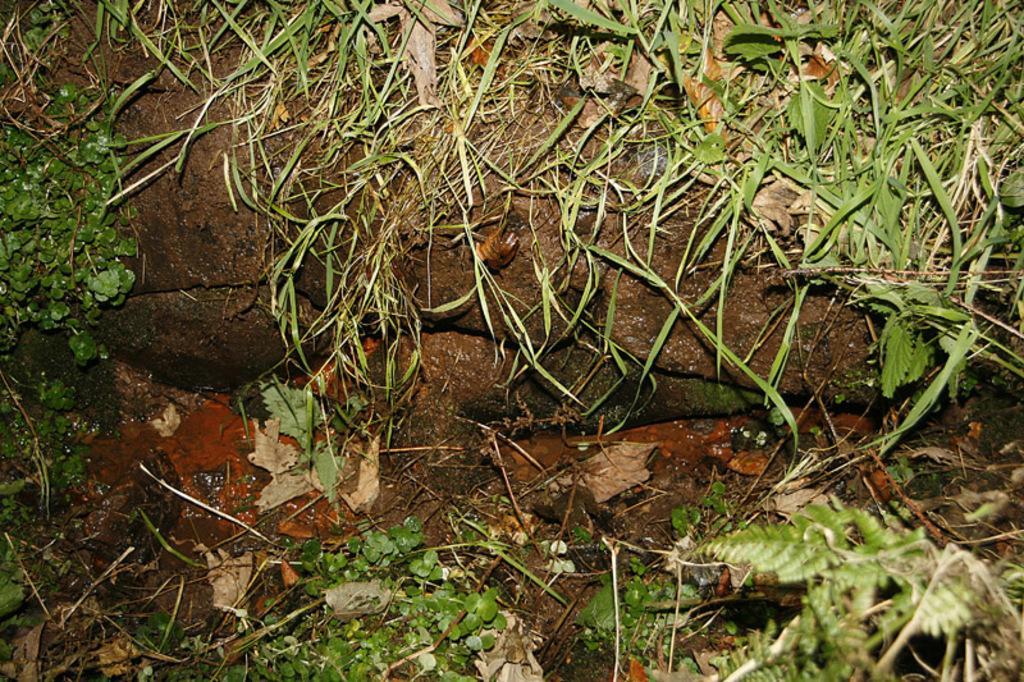How would you summarize this image in a sentence or two? In this picture we can see the wall and it is wet. We can see the green grass, leaves and the tiny plants. 